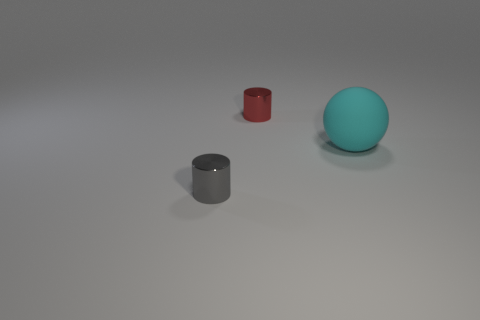Add 3 large cyan balls. How many objects exist? 6 Subtract all balls. How many objects are left? 2 Add 1 cyan rubber balls. How many cyan rubber balls exist? 2 Subtract 0 blue blocks. How many objects are left? 3 Subtract all tiny red metal things. Subtract all tiny gray cylinders. How many objects are left? 1 Add 3 small gray metal cylinders. How many small gray metal cylinders are left? 4 